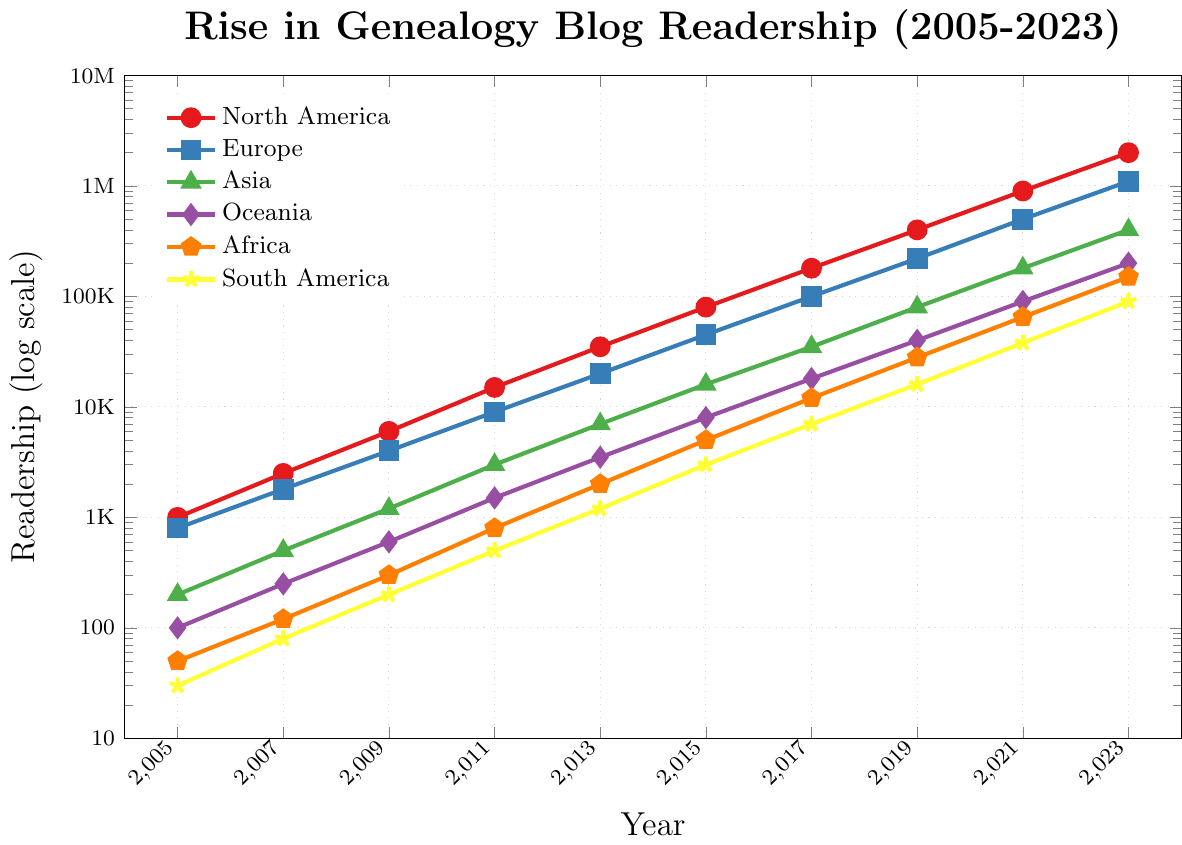Which region showed the highest readership in 2023? To find the region with the highest readership in 2023, observe the data points for all regions in the year 2023. North America shows the highest value with 2,000,000 readers.
Answer: North America Which two regions had the closest readership values in 2023? In 2023, compare the readership values for all the regions. Oceania and Africa have readerships of 200,000 and 150,000, respectively, which are the closest figures.
Answer: Oceania and Africa What is the approximate growth ratio of North American readership from 2005 to 2023? The North American readership in 2005 is 1,000, and in 2023 it is 2,000,000. The growth ratio is calculated as 2,000,000 / 1,000.
Answer: 2000 How does the growth of South American readership compare to African readership from 2005 to 2023? In 2005, South America had 30 readers, and in 2023 it had 90,000 readers. Africa had 50 readers in 2005 and 150,000 in 2023. So, the growth factors are 90,000 / 30 for South America and 150,000 / 50 for Africa. These ratios (3000 and 3000) are the same, indicating similar growth patterns.
Answer: Similar Which region's readership surpassed 1,000,000 readers first and when? Identify the year when each region's readership first exceeded 1,000,000. For Europe, it surpassed 1,000,000 in 2023. No other region surpassed this mark by 2023.
Answer: Europe in 2023 Can you identify the general trend in the genealogy blog readership across all regions? The general trend can be inferred by looking at the slope of each line, which shows an increasing pattern in log scale, indicating exponential growth for all regions.
Answer: Increasing What was the readership  ratio of Asia to Europe in 2015? To find the ratio of readership between Asia and Europe in 2015, divide the readership value of Asia (16,000) by that of Europe (45,000).
Answer: Approximately 0.36 What years did the rate of readership increase significantly across regions? Significant increases are indicated by sharp slopes in the lines. For instance, between 2011 and 2013, there is a noticeable rise across many regions, marked by steeper lines.
Answer: 2011-2013 Which region had the slowest growth in readership relative to its initial value? Compute the growth ratios for each region from 2005 to 2023. South America grew from 30 to 90,000, which is a factor of 3,000. This is lower compared to the growth rates of other regions such as North America.
Answer: South America Between 2019 and 2021, which region experienced the largest increase in absolute readership? Calculate the difference in readership from 2019 to 2021 for each region. North America experienced the largest increase, going from 400,000 to 900,000, an increase of 500,000.
Answer: North America 